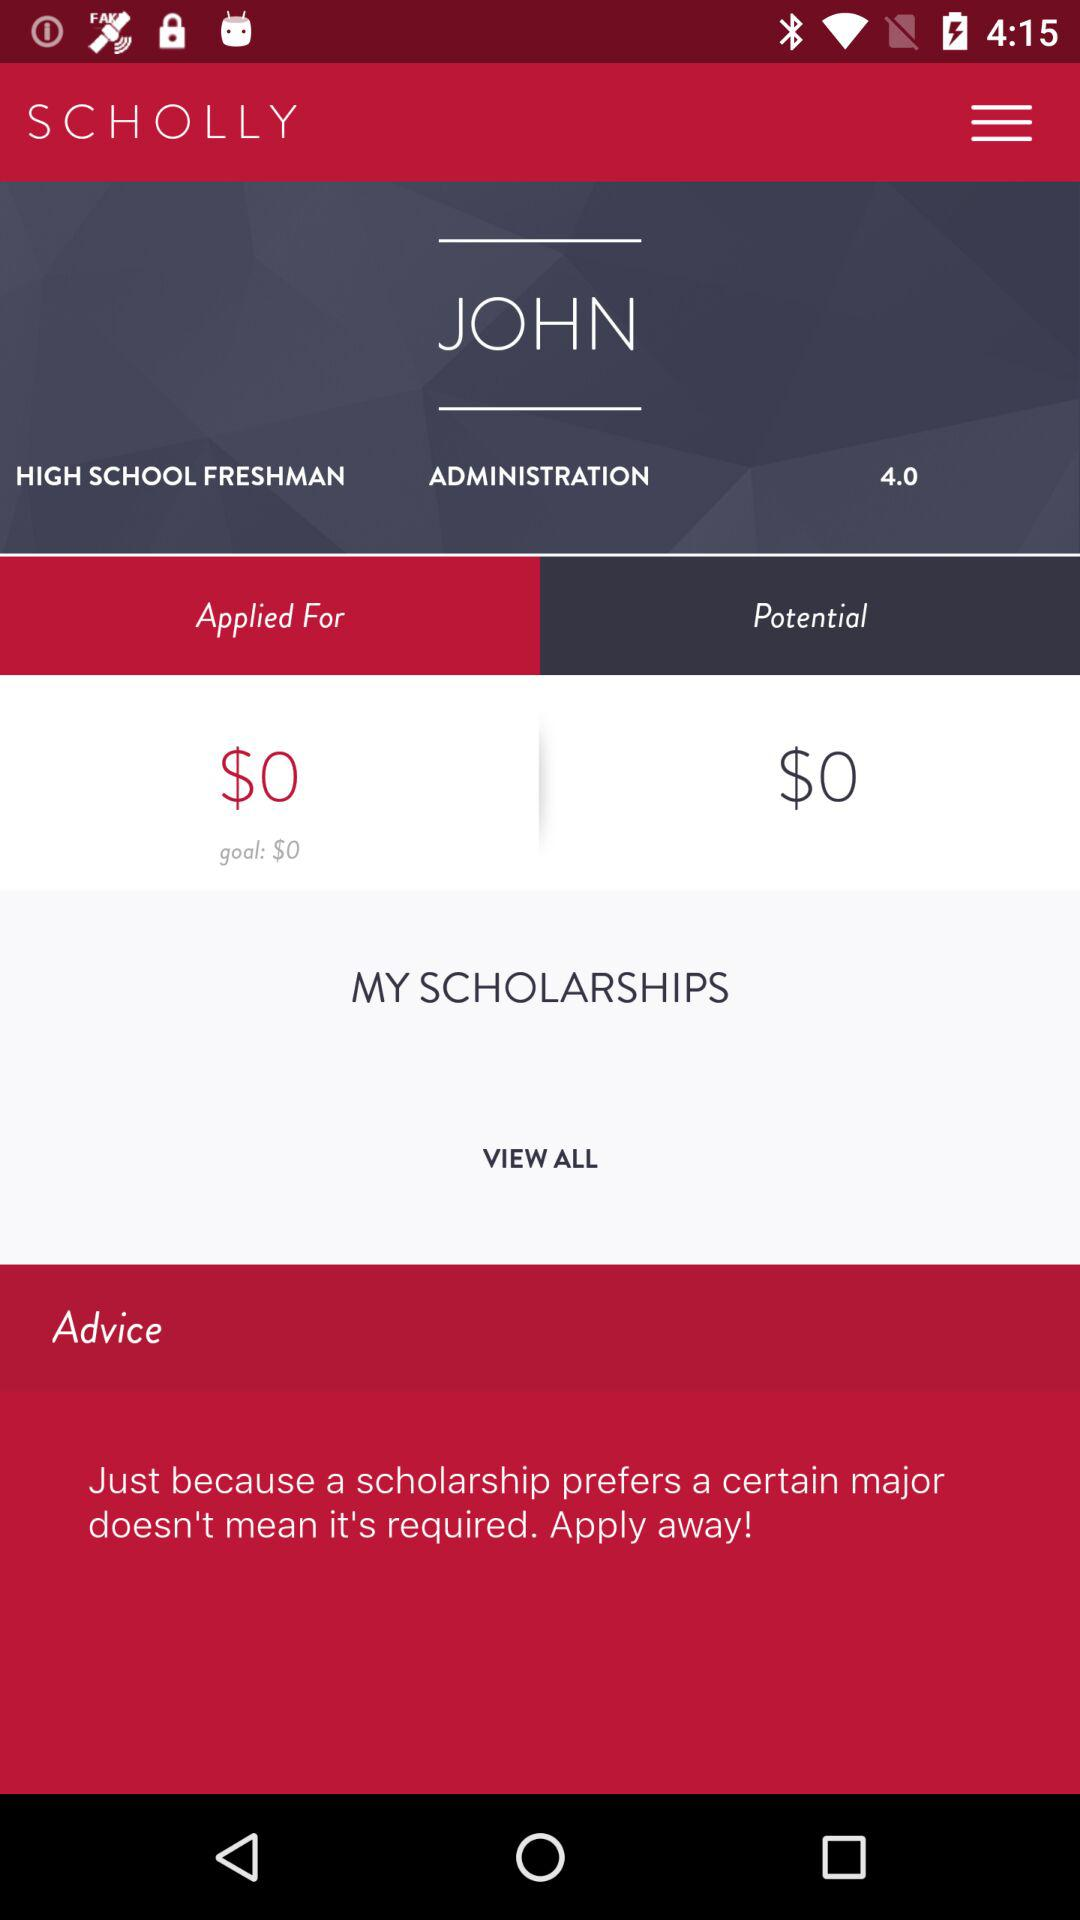What is the currency for the goal? The currency for the goal is dollars. 